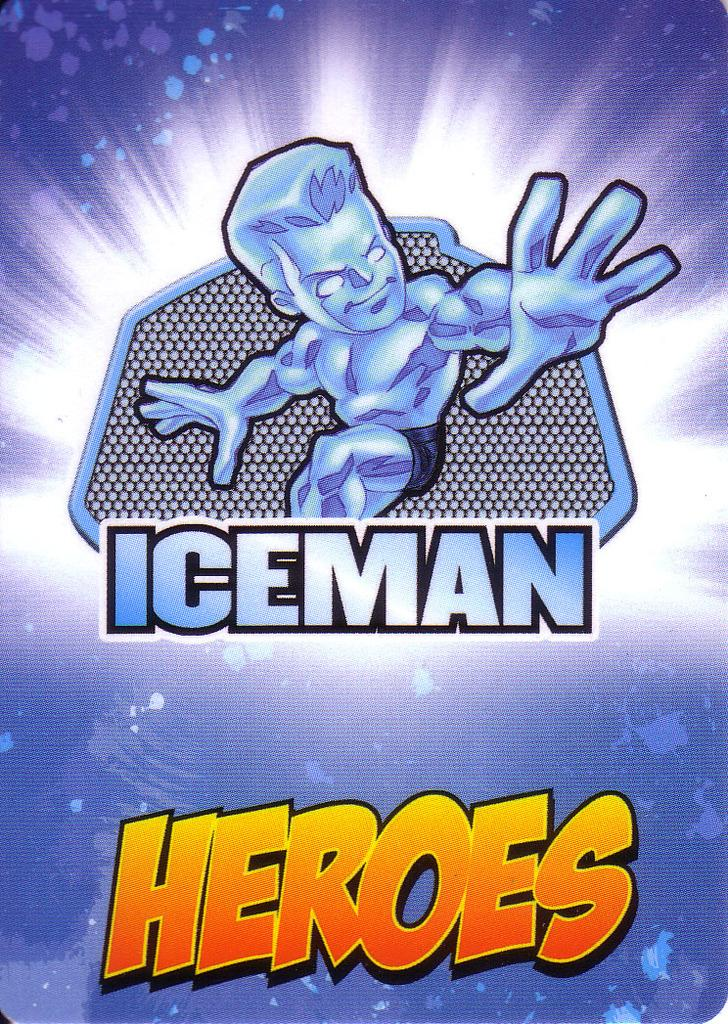<image>
Write a terse but informative summary of the picture. A blue Iceman trading card from the Heroes collection. 